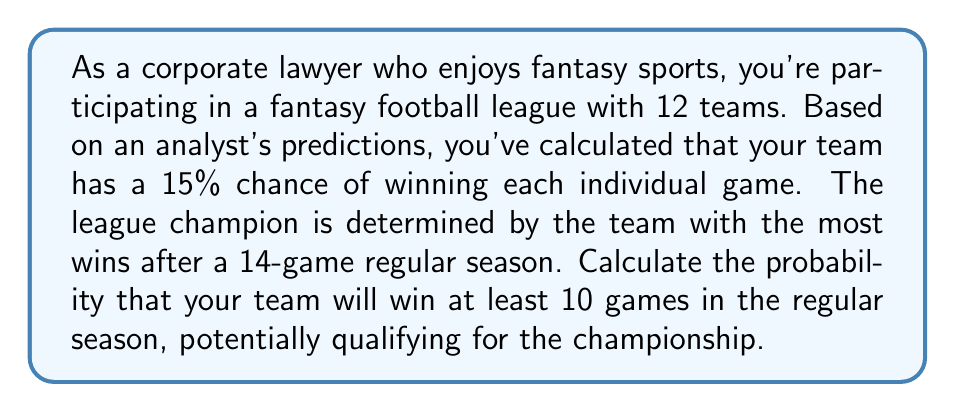Show me your answer to this math problem. To solve this problem, we need to use the binomial probability distribution. Here's a step-by-step explanation:

1) Let $X$ be the random variable representing the number of games won in a 14-game season.

2) We know:
   - $n = 14$ (number of games)
   - $p = 0.15$ (probability of winning each game)
   - We want $P(X \geq 10)$

3) The probability of winning at least 10 games is the sum of probabilities of winning 10, 11, 12, 13, or 14 games:

   $P(X \geq 10) = P(X = 10) + P(X = 11) + P(X = 12) + P(X = 13) + P(X = 14)$

4) We can calculate each of these probabilities using the binomial probability formula:

   $P(X = k) = \binom{n}{k} p^k (1-p)^{n-k}$

   Where $\binom{n}{k}$ is the binomial coefficient, calculated as:

   $\binom{n}{k} = \frac{n!}{k!(n-k)!}$

5) Let's calculate each probability:

   $P(X = 10) = \binom{14}{10} (0.15)^{10} (0.85)^4 = 0.0001306$
   $P(X = 11) = \binom{14}{11} (0.15)^{11} (0.85)^3 = 0.0000144$
   $P(X = 12) = \binom{14}{12} (0.15)^{12} (0.85)^2 = 0.0000011$
   $P(X = 13) = \binom{14}{13} (0.15)^{13} (0.85)^1 = 0.0000001$
   $P(X = 14) = \binom{14}{14} (0.15)^{14} (0.85)^0 = 0.0000000$

6) Sum these probabilities:

   $P(X \geq 10) = 0.0001306 + 0.0000144 + 0.0000011 + 0.0000001 + 0.0000000 = 0.0001462$
Answer: The probability of winning at least 10 games in the 14-game regular season is approximately $0.0001462$ or about $0.01462\%$. 